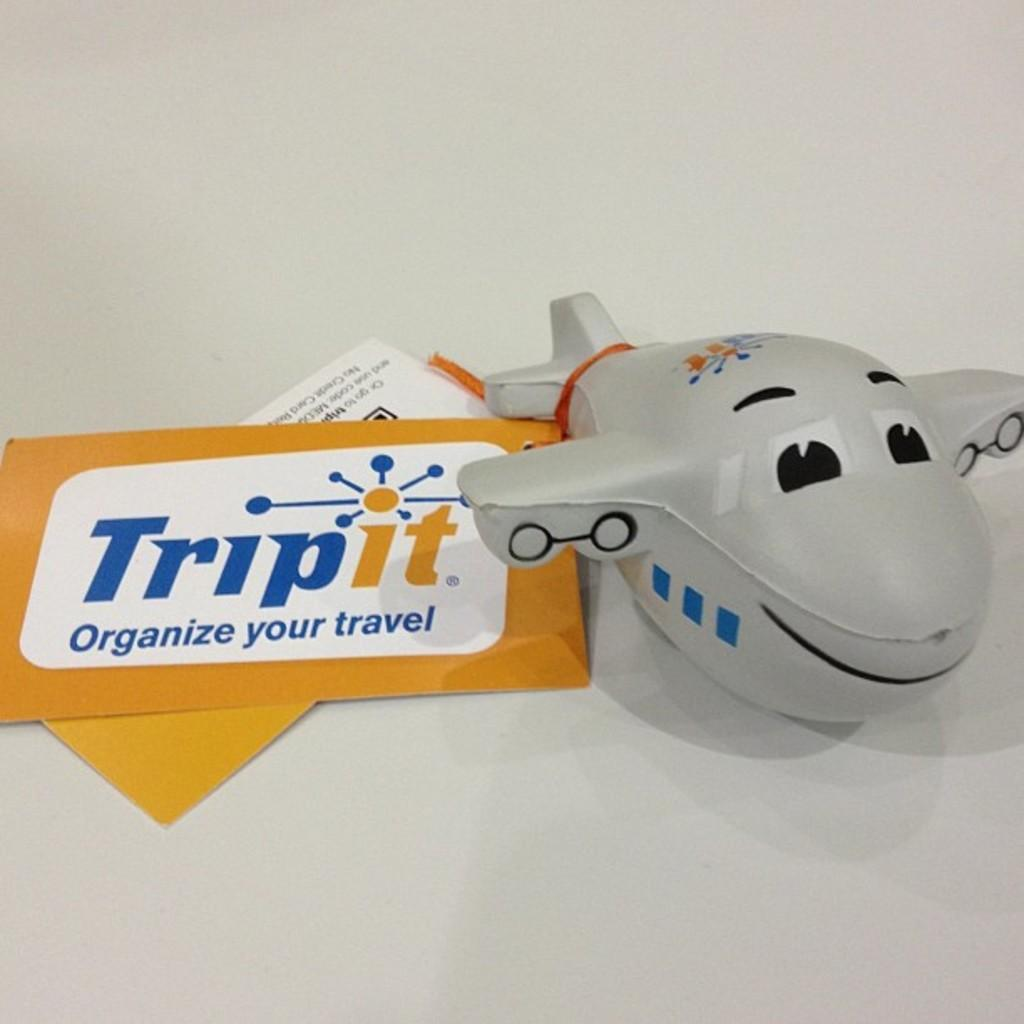<image>
Write a terse but informative summary of the picture. A small toy airplane mascot for the company Tripit. 